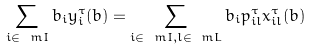<formula> <loc_0><loc_0><loc_500><loc_500>\sum _ { i \in \ m I } b _ { i } y _ { i } ^ { \tau } ( b ) = \sum _ { i \in \ m I , l \in \ m L } b _ { i } p _ { i l } ^ { \tau } x _ { i l } ^ { \tau } ( b )</formula> 